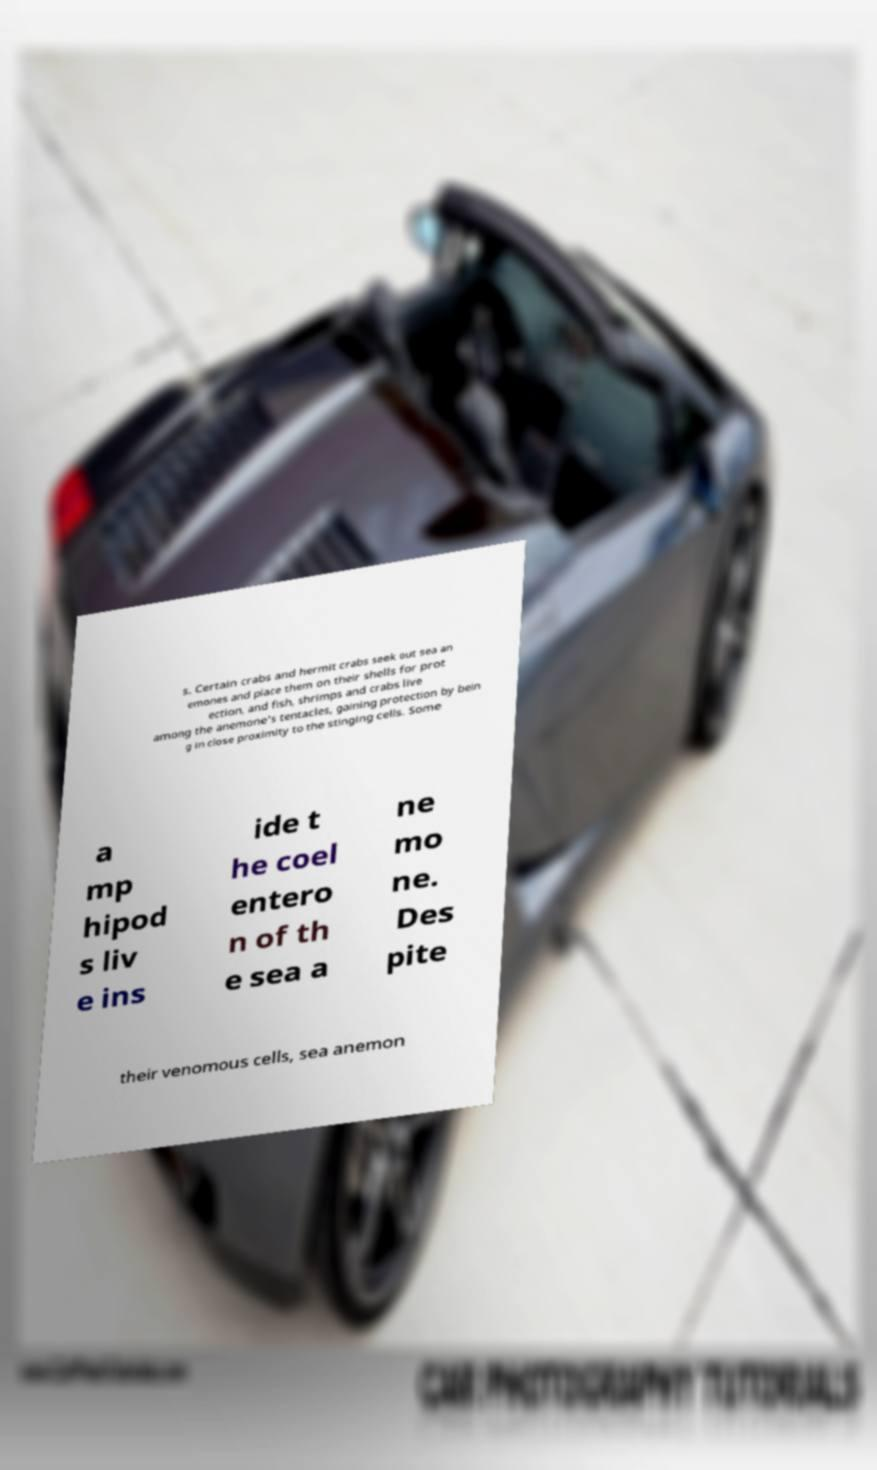Can you accurately transcribe the text from the provided image for me? s. Certain crabs and hermit crabs seek out sea an emones and place them on their shells for prot ection, and fish, shrimps and crabs live among the anemone's tentacles, gaining protection by bein g in close proximity to the stinging cells. Some a mp hipod s liv e ins ide t he coel entero n of th e sea a ne mo ne. Des pite their venomous cells, sea anemon 